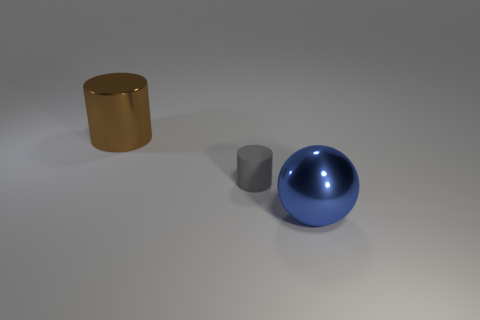Add 1 big objects. How many objects exist? 4 Subtract all spheres. How many objects are left? 2 Add 1 shiny spheres. How many shiny spheres exist? 2 Subtract 0 green cubes. How many objects are left? 3 Subtract all large shiny things. Subtract all small blue things. How many objects are left? 1 Add 2 large brown objects. How many large brown objects are left? 3 